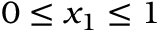Convert formula to latex. <formula><loc_0><loc_0><loc_500><loc_500>0 \leq x _ { 1 } \leq 1</formula> 